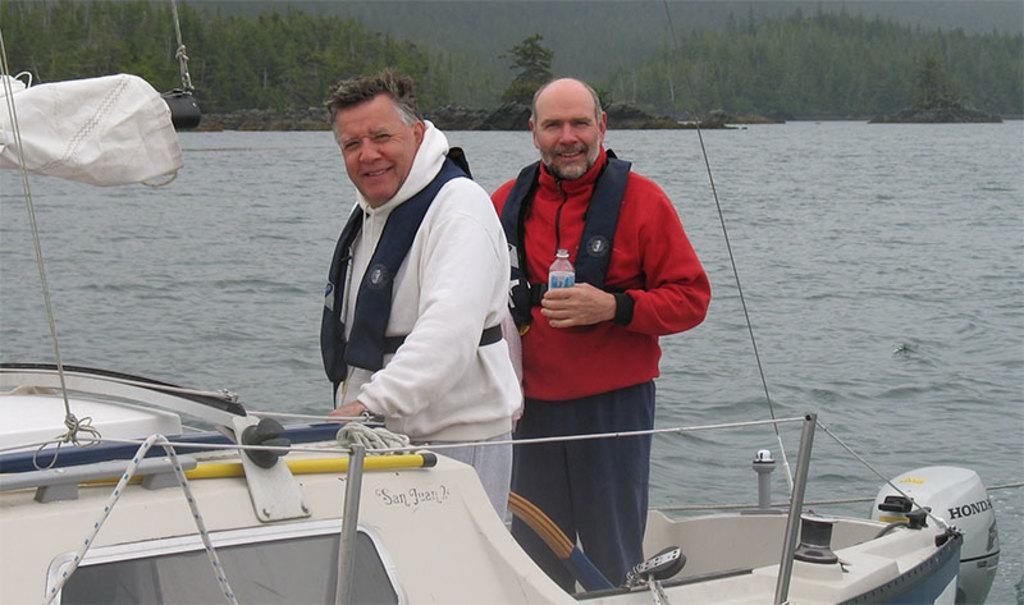Could you give a brief overview of what you see in this image? In this picture we can see two men standing and smiling, cloth, rods, ropes on a boat and a man holding a bottle with his hand and this boat is on water and in the background we can see trees. 